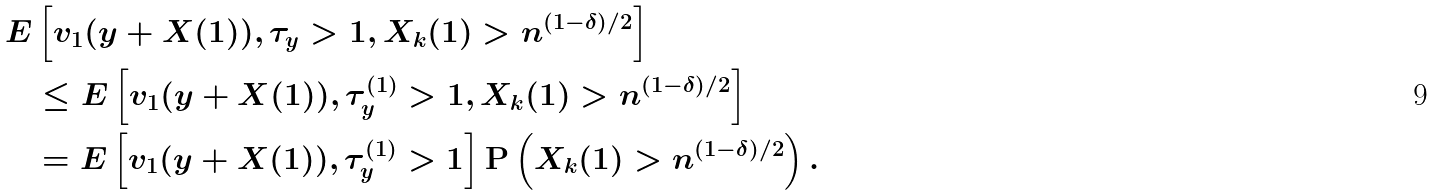<formula> <loc_0><loc_0><loc_500><loc_500>E & \left [ v _ { 1 } ( y + X ( 1 ) ) , \tau _ { y } > 1 , X _ { k } ( 1 ) > n ^ { ( 1 - \delta ) / 2 } \right ] \\ & \leq E \left [ v _ { 1 } ( y + X ( 1 ) ) , \tau ^ { ( 1 ) } _ { y } > 1 , X _ { k } ( 1 ) > n ^ { ( 1 - \delta ) / 2 } \right ] \\ & = E \left [ v _ { 1 } ( y + X ( 1 ) ) , \tau _ { y } ^ { ( 1 ) } > 1 \right ] \mathbf P \left ( X _ { k } ( 1 ) > n ^ { ( 1 - \delta ) / 2 } \right ) .</formula> 